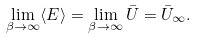Convert formula to latex. <formula><loc_0><loc_0><loc_500><loc_500>\lim _ { \beta \rightarrow \infty } \langle E \rangle = \lim _ { \beta \rightarrow \infty } \bar { U } = \bar { U } _ { \infty } .</formula> 